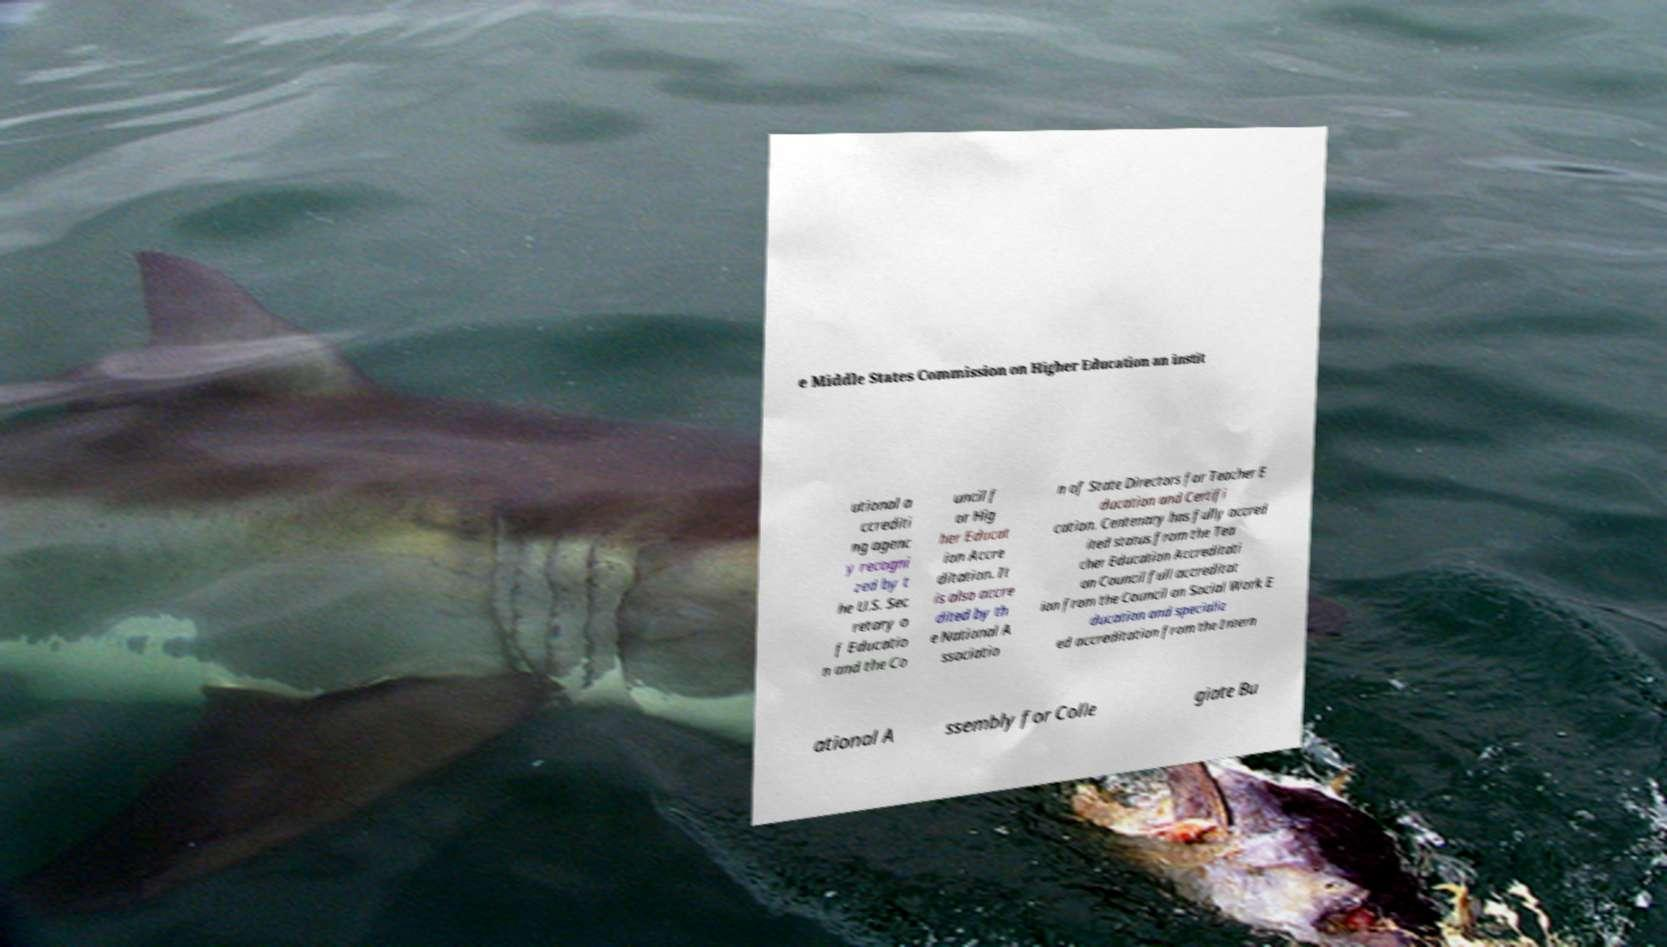Can you read and provide the text displayed in the image?This photo seems to have some interesting text. Can you extract and type it out for me? e Middle States Commission on Higher Education an instit utional a ccrediti ng agenc y recogni zed by t he U.S. Sec retary o f Educatio n and the Co uncil f or Hig her Educat ion Accre ditation. It is also accre dited by th e National A ssociatio n of State Directors for Teacher E ducation and Certifi cation. Centenary has fully accred ited status from the Tea cher Education Accreditati on Council full accreditat ion from the Council on Social Work E ducation and specializ ed accreditation from the Intern ational A ssembly for Colle giate Bu 